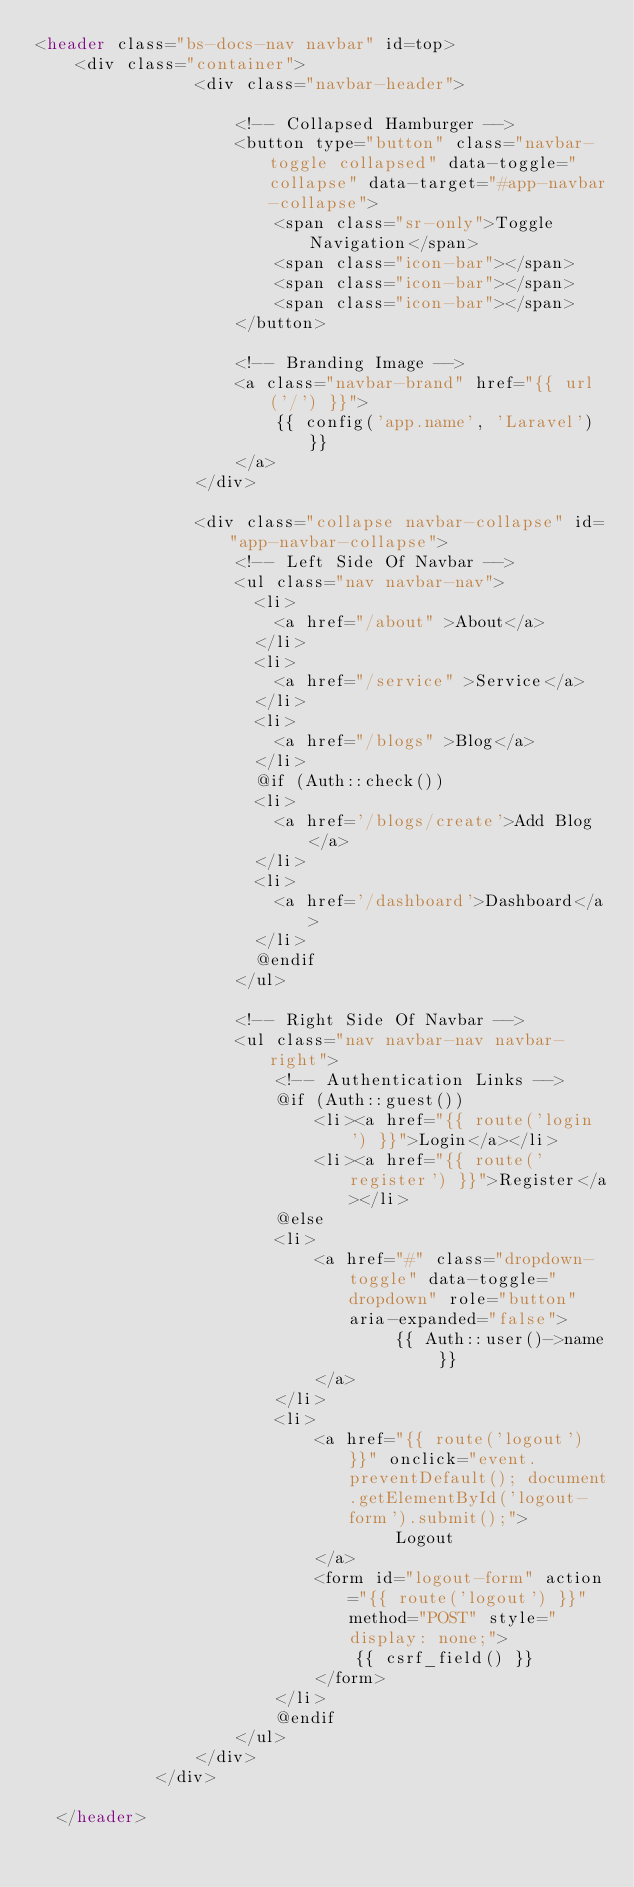<code> <loc_0><loc_0><loc_500><loc_500><_PHP_><header class="bs-docs-nav navbar" id=top>
    <div class="container">
                <div class="navbar-header">

                    <!-- Collapsed Hamburger -->
                    <button type="button" class="navbar-toggle collapsed" data-toggle="collapse" data-target="#app-navbar-collapse">
                        <span class="sr-only">Toggle Navigation</span>
                        <span class="icon-bar"></span>
                        <span class="icon-bar"></span>
                        <span class="icon-bar"></span>
                    </button>

                    <!-- Branding Image -->
                    <a class="navbar-brand" href="{{ url('/') }}">
                        {{ config('app.name', 'Laravel') }}
                    </a>
                </div>

                <div class="collapse navbar-collapse" id="app-navbar-collapse">
                    <!-- Left Side Of Navbar -->
                    <ul class="nav navbar-nav">
                      <li> 
                        <a href="/about" >About</a>
                      </li>
                      <li> 
                        <a href="/service" >Service</a>
                      </li>
                      <li> 
                        <a href="/blogs" >Blog</a>
                      </li>
                      @if (Auth::check())
                      <li>
                        <a href='/blogs/create'>Add Blog</a>
                      </li>
                      <li>
                        <a href='/dashboard'>Dashboard</a>
                      </li>
                      @endif
                    </ul>

                    <!-- Right Side Of Navbar -->
                    <ul class="nav navbar-nav navbar-right">
                        <!-- Authentication Links -->
                        @if (Auth::guest())
                            <li><a href="{{ route('login') }}">Login</a></li>
                            <li><a href="{{ route('register') }}">Register</a></li>
                        @else
                        <li>
                            <a href="#" class="dropdown-toggle" data-toggle="dropdown" role="button" aria-expanded="false">
                                    {{ Auth::user()->name }}
                            </a>
                        </li>
                        <li>
                            <a href="{{ route('logout') }}" onclick="event.preventDefault(); document.getElementById('logout-form').submit();">
                                    Logout
                            </a>
                            <form id="logout-form" action="{{ route('logout') }}" method="POST" style="display: none;">
                                {{ csrf_field() }}
                            </form>
                        </li>
                        @endif
                    </ul>
                </div>
            </div>

  </header></code> 